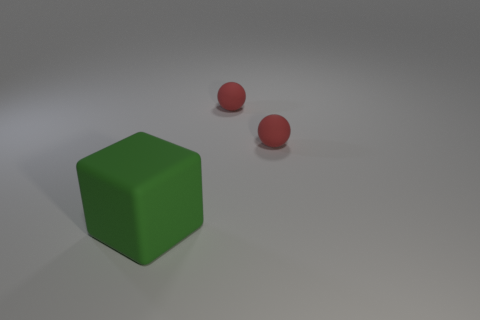How could the lighting condition affect the perception of the objects? The lighting in this image appears to be ambient and diffused, producing soft shadows that do not overpower the objects. Such lighting conditions enhance the visual clarity of the shapes, allowing the viewer to clearly distinguish between the green cube and the red spheres. The light seems to be coming from above, slightly favoring the left side, which creates a gentle gradient of illumination that adds depth and dimension to the objects. 